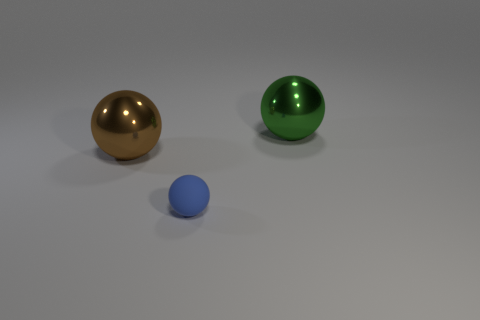Subtract all green spheres. Subtract all cyan cylinders. How many spheres are left? 2 Add 2 green rubber cylinders. How many objects exist? 5 Subtract 0 green cylinders. How many objects are left? 3 Subtract all tiny blue rubber things. Subtract all big brown metal spheres. How many objects are left? 1 Add 1 small blue things. How many small blue things are left? 2 Add 2 large brown shiny objects. How many large brown shiny objects exist? 3 